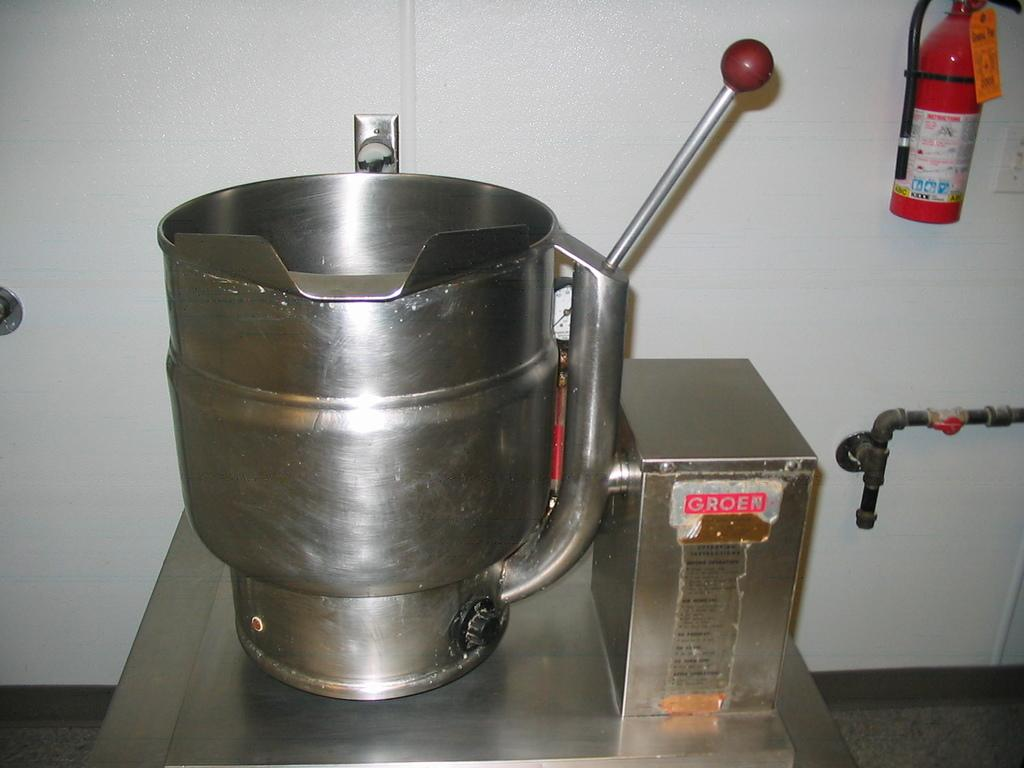Provide a one-sentence caption for the provided image. A metal box reads Groen in silver letters on a red background. 